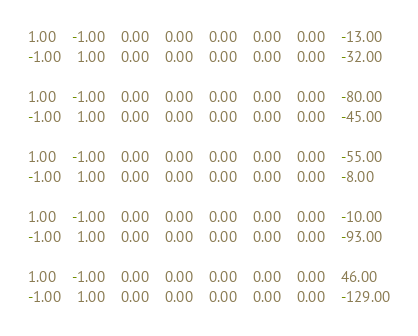<code> <loc_0><loc_0><loc_500><loc_500><_Matlab_>1.00	-1.00	0.00	0.00	0.00	0.00	0.00	-13.00
-1.00	1.00	0.00	0.00	0.00	0.00	0.00	-32.00

1.00	-1.00	0.00	0.00	0.00	0.00	0.00	-80.00
-1.00	1.00	0.00	0.00	0.00	0.00	0.00	-45.00

1.00	-1.00	0.00	0.00	0.00	0.00	0.00	-55.00
-1.00	1.00	0.00	0.00	0.00	0.00	0.00	-8.00

1.00	-1.00	0.00	0.00	0.00	0.00	0.00	-10.00
-1.00	1.00	0.00	0.00	0.00	0.00	0.00	-93.00

1.00	-1.00	0.00	0.00	0.00	0.00	0.00	46.00
-1.00	1.00	0.00	0.00	0.00	0.00	0.00	-129.00
</code> 